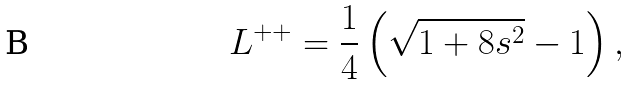Convert formula to latex. <formula><loc_0><loc_0><loc_500><loc_500>L ^ { + + } = \frac { 1 } { 4 } \left ( \sqrt { 1 + 8 s ^ { 2 } } - 1 \right ) ,</formula> 